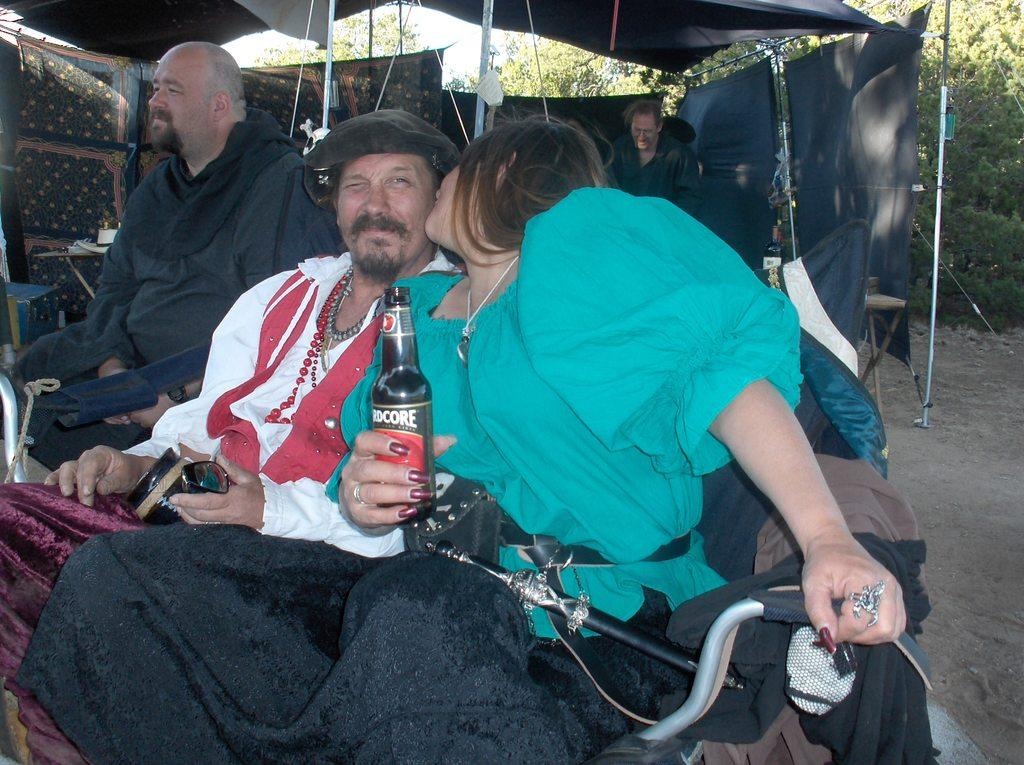How many people are sitting in the image? There are three persons sitting on chairs in the image. What object can be seen in the image besides the chairs and people? There is a bottle in the image. What type of shelter is present in the image? There is a tent in the image. What can be seen in the background of the image? Trees and the sky are visible in the background of the image. What type of crib can be seen in the image? There is no crib present in the image. What time of day is it in the image, given the presence of morning light? The provided facts do not mention the time of day or any specific lighting conditions, so it cannot be determined from the image. 